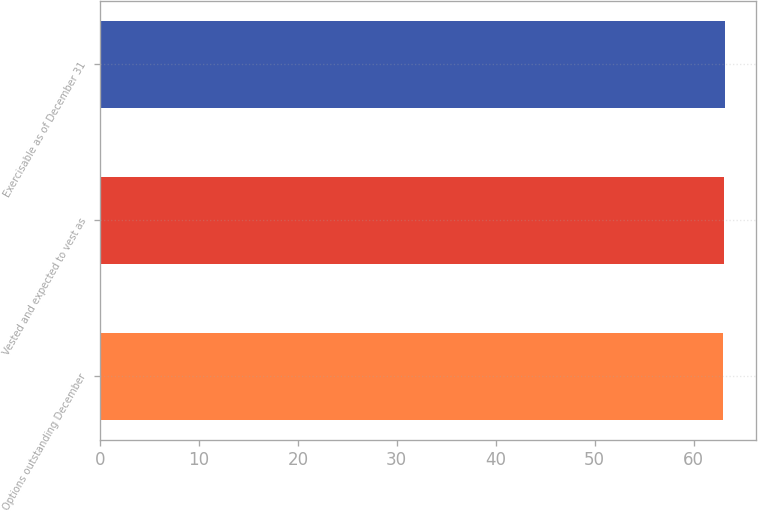<chart> <loc_0><loc_0><loc_500><loc_500><bar_chart><fcel>Options outstanding December<fcel>Vested and expected to vest as<fcel>Exercisable as of December 31<nl><fcel>63<fcel>63.1<fcel>63.2<nl></chart> 